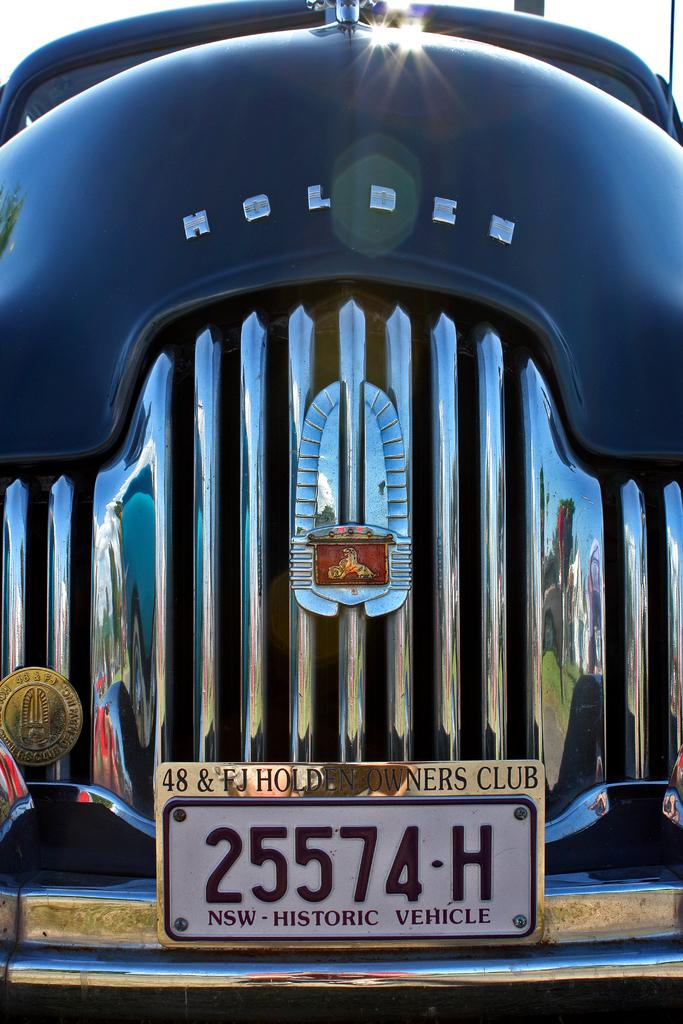What is the main subject of the picture? The main subject of the picture is a car. What part of the car is visible in the image? The bonnet of the car is visible in the image. Is there any identifying information about the car in the picture? Yes, there is a registration plate in the picture. What type of wound can be seen on the turkey in the image? There is no turkey present in the image, and therefore no wound can be observed. 